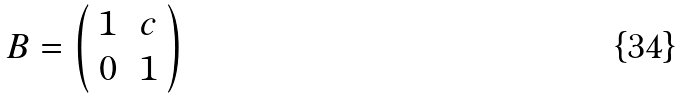Convert formula to latex. <formula><loc_0><loc_0><loc_500><loc_500>B = \left ( \begin{array} { c c } 1 & \, c \\ 0 & \, 1 \end{array} \right )</formula> 